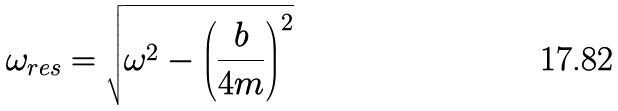Convert formula to latex. <formula><loc_0><loc_0><loc_500><loc_500>\omega _ { r e s } = { \sqrt { \omega ^ { 2 } - \left ( { \frac { b } { 4 m } } \right ) ^ { 2 } } }</formula> 